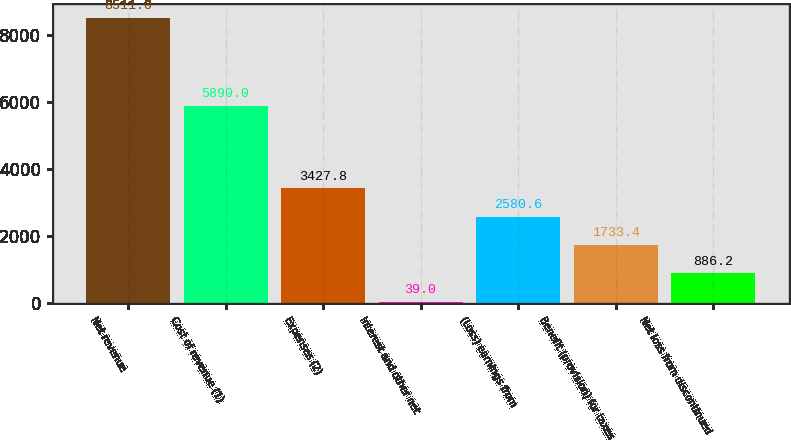<chart> <loc_0><loc_0><loc_500><loc_500><bar_chart><fcel>Net revenue<fcel>Cost of revenue (1)<fcel>Expenses (2)<fcel>Interest and other net<fcel>(Loss) earnings from<fcel>Benefit (provision) for taxes<fcel>Net loss from discontinued<nl><fcel>8511<fcel>5890<fcel>3427.8<fcel>39<fcel>2580.6<fcel>1733.4<fcel>886.2<nl></chart> 